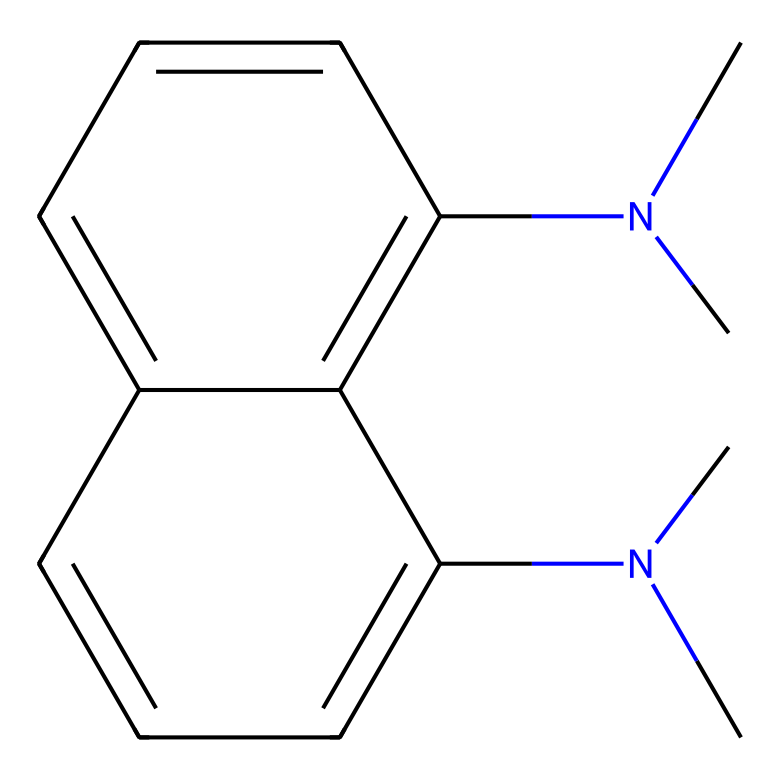How many nitrogen atoms are in the structure? By examining the SMILES representation, we can identify the presence of two dimethylamino groups (indicated by "N(C)C"), which each contain one nitrogen atom. Therefore, counting these results in a total of two nitrogen atoms.
Answer: 2 What is the name of this chemical? The SMILES code includes information about the structure and substituents of the molecule, leading us to identify it as 1,8-bis(dimethylamino)naphthalene, based on the recognition of the naphthalene core and the two dimethylamino groups.
Answer: 1,8-bis(dimethylamino)naphthalene What type of bonding is predominant in this compound? Upon analyzing the structure represented by the SMILES, we can see that the connections made between the carbon atoms suggest a predominance of covalent bonds, typical in organic molecules where atoms share electrons.
Answer: covalent Which property makes it a superbase? The existence of multiple nitrogen atoms in the structure contributes to its ability to accept protons due to the presence of lone pairs on these nitrogens, which is the defining characteristic of superbases.
Answer: proton affinity How many rings are present in the structure? A careful inspection of the naphthalene core in the SMILES reveals that it consists of two fused benzene rings, indicating there are two rings total in the molecular structure.
Answer: 2 What is the contribution of dimethylamino groups to its chemical properties? The dimethylamino groups provide electron-donating effects due to the presence of lone pairs on nitrogen, which enhances the molecule's ability to accept protons or form bonds with electrophiles, characteristic of superbases.
Answer: electron-donating Is this compound soluble in water? The hydrophobic nature of the naphthalene component and the bulkiness of the dimethylamino groups generally suggest that this chemical is not readily soluble in water, as such structures are often not compatible with polar solvents.
Answer: no 